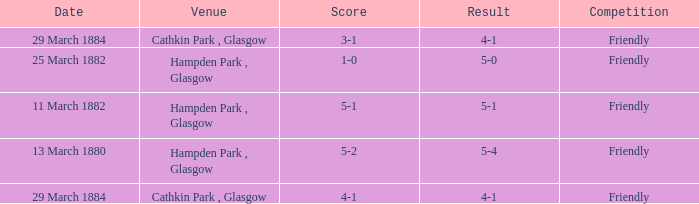Which item resulted in a score of 4-1? 3-1, 4-1. 